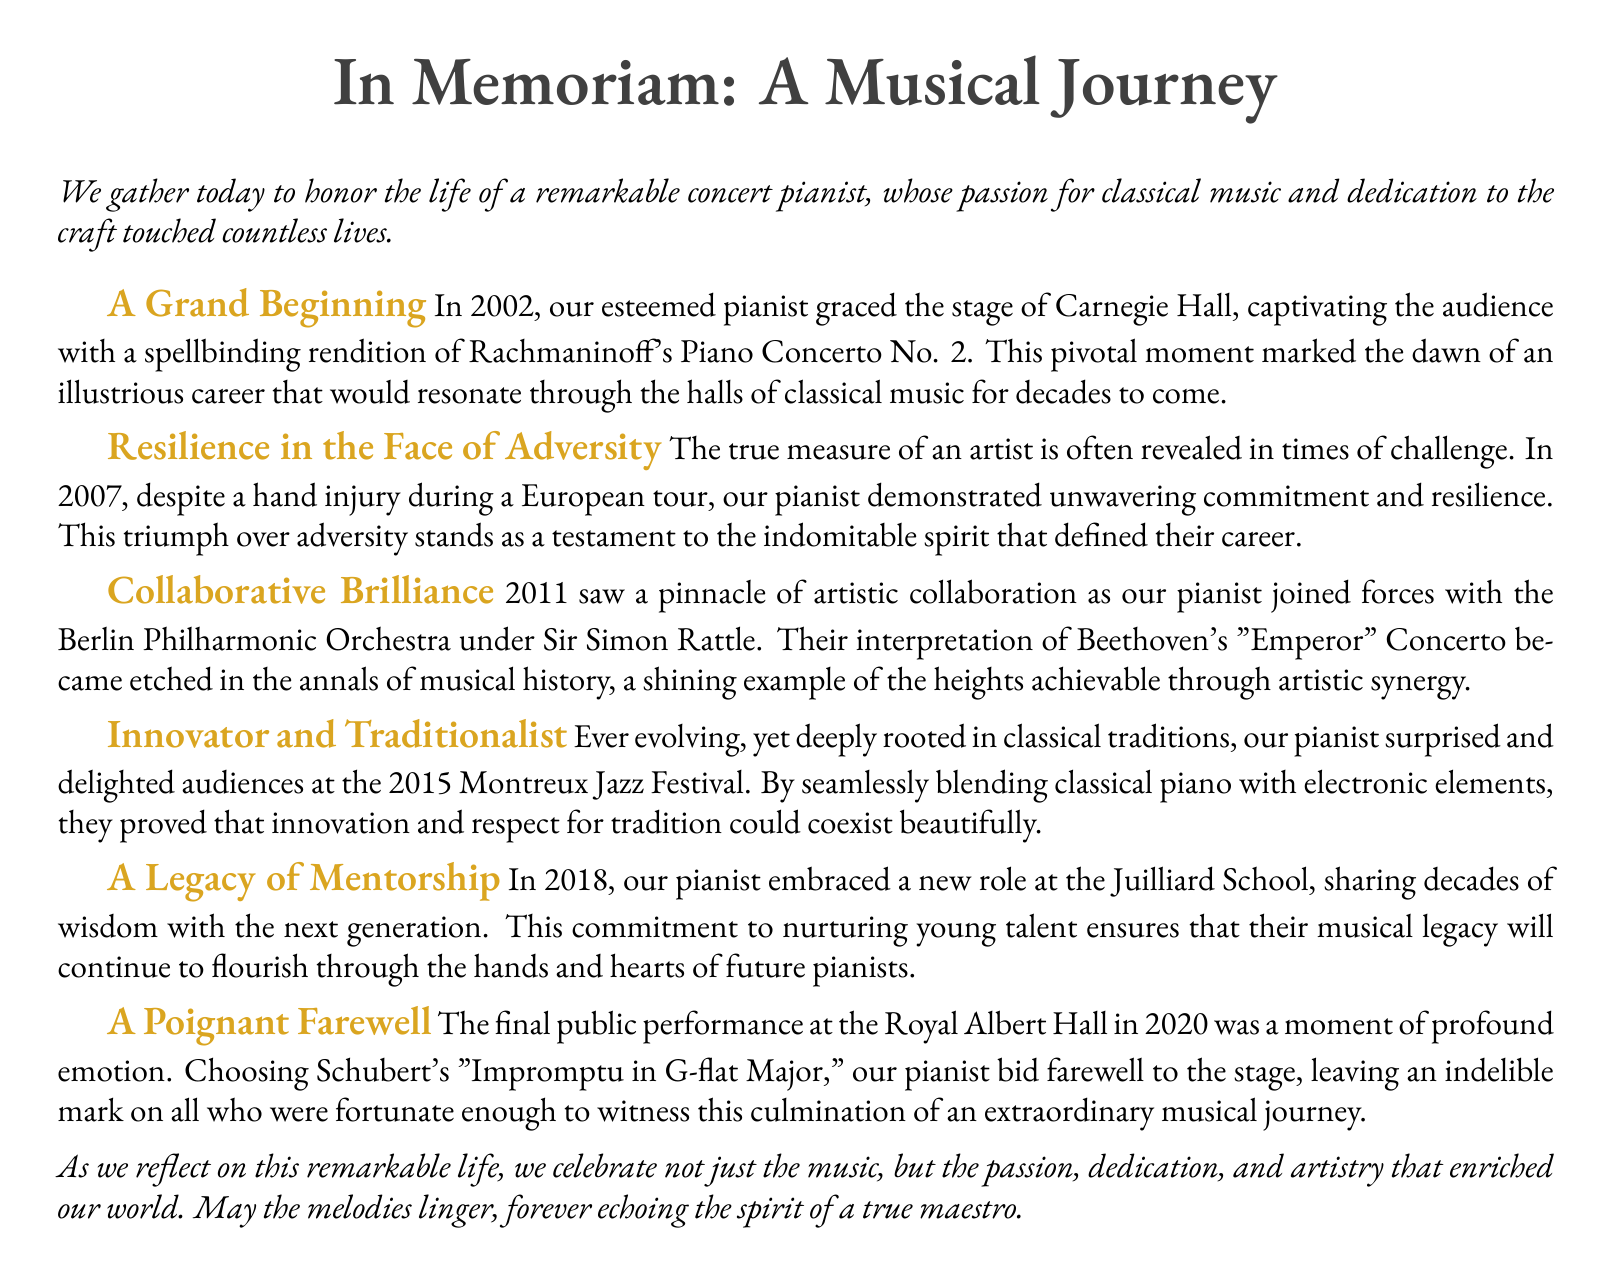What year did the pianist perform at Carnegie Hall? The document states that the performance at Carnegie Hall was in 2002.
Answer: 2002 What piece did the pianist perform at their final public performance? The document mentions that they chose Schubert's "Impromptu in G-flat Major" for their farewell performance.
Answer: Schubert's "Impromptu in G-flat Major" Who conducted the Berlin Philharmonic Orchestra during the collaboration? The document specifies that Sir Simon Rattle conducted the Berlin Philharmonic Orchestra.
Answer: Sir Simon Rattle In what year did the pianist take on a mentorship role at Juilliard? The document notes that the pianist began their mentorship at Juilliard in 2018.
Answer: 2018 What challenge did the pianist face during their European tour? The document indicates that the pianist suffered a hand injury during the tour.
Answer: Hand injury How did the pianist innovate at the Montreux Jazz Festival? The document mentions that the pianist blended classical piano with electronic elements.
Answer: Blended classical piano with electronic elements What does the eulogy celebrate aside from music? The document states that the eulogy celebrates the passion, dedication, and artistry of the pianist.
Answer: Passion, dedication, and artistry What major event marked the beginning of the pianist's career? The document indicates that their performance at Carnegie Hall marked the beginning of their career.
Answer: Performance at Carnegie Hall How did the pianist's collaboration with the Berlin Philharmonic Orchestra contribute to musical history? The document describes their interpretation of Beethoven's "Emperor" Concerto as a shining example of artistic synergy.
Answer: Artistic synergy 